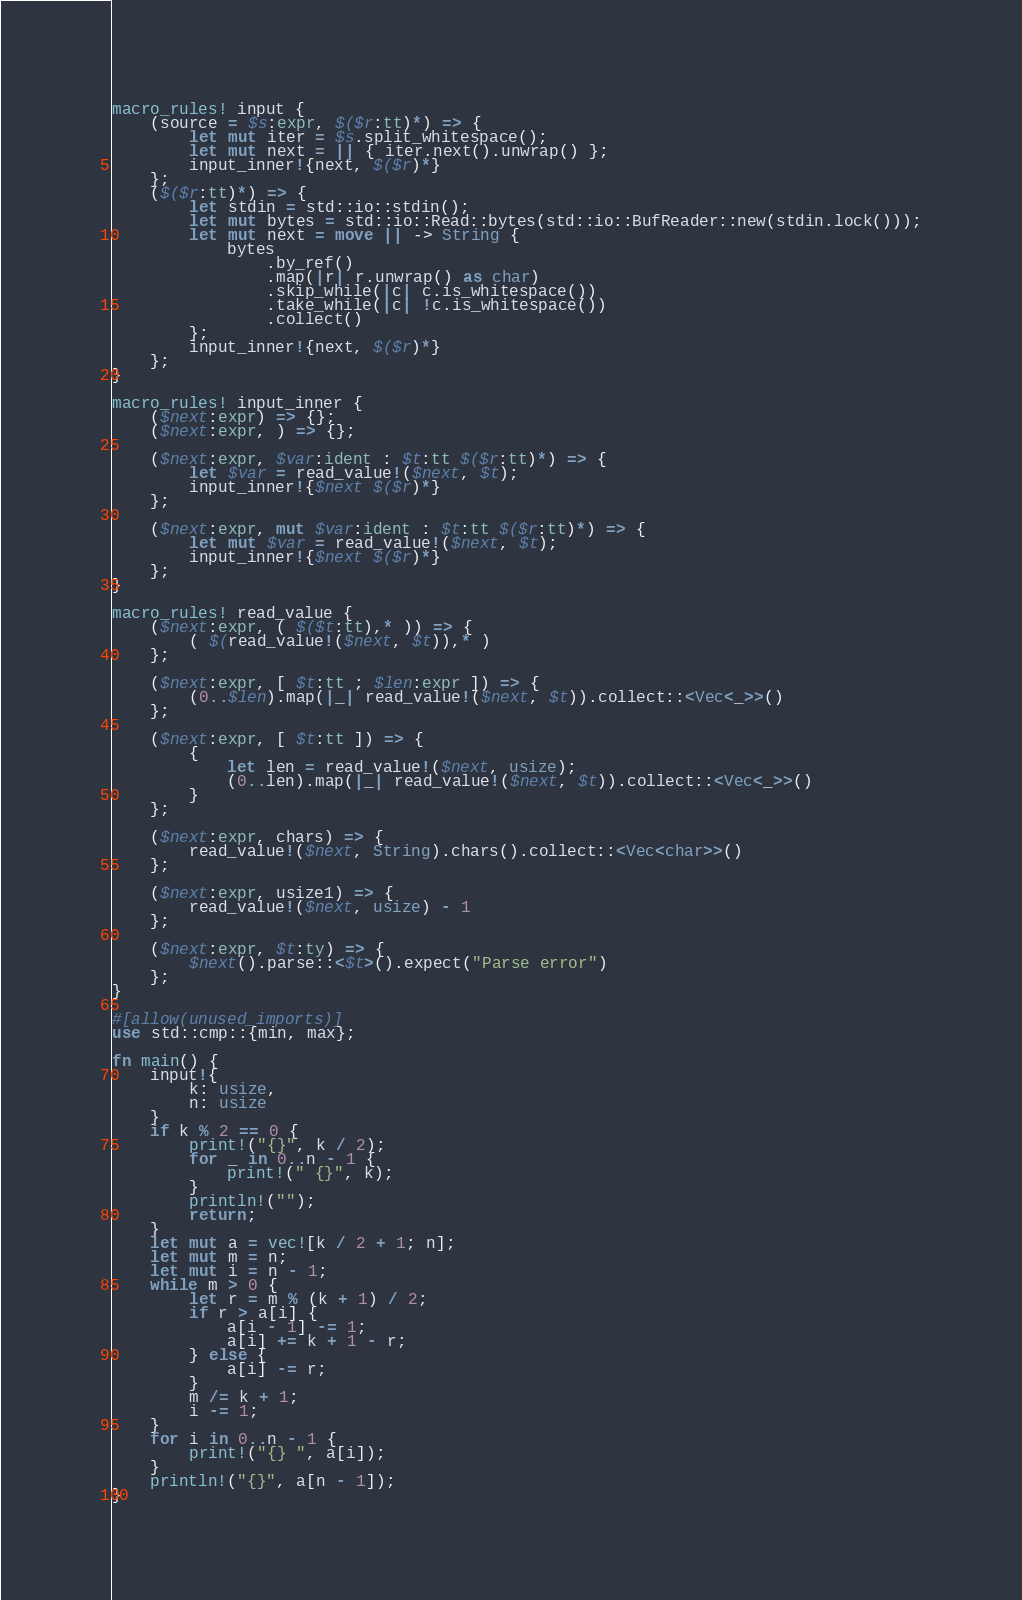<code> <loc_0><loc_0><loc_500><loc_500><_Rust_>macro_rules! input {
    (source = $s:expr, $($r:tt)*) => {
        let mut iter = $s.split_whitespace();
        let mut next = || { iter.next().unwrap() };
        input_inner!{next, $($r)*}
    };
    ($($r:tt)*) => {
        let stdin = std::io::stdin();
        let mut bytes = std::io::Read::bytes(std::io::BufReader::new(stdin.lock()));
        let mut next = move || -> String {
            bytes
                .by_ref()
                .map(|r| r.unwrap() as char)
                .skip_while(|c| c.is_whitespace())
                .take_while(|c| !c.is_whitespace())
                .collect()
        };
        input_inner!{next, $($r)*}
    };
}

macro_rules! input_inner {
    ($next:expr) => {};
    ($next:expr, ) => {};

    ($next:expr, $var:ident : $t:tt $($r:tt)*) => {
        let $var = read_value!($next, $t);
        input_inner!{$next $($r)*}
    };

    ($next:expr, mut $var:ident : $t:tt $($r:tt)*) => {
        let mut $var = read_value!($next, $t);
        input_inner!{$next $($r)*}
    };
}

macro_rules! read_value {
    ($next:expr, ( $($t:tt),* )) => {
        ( $(read_value!($next, $t)),* )
    };

    ($next:expr, [ $t:tt ; $len:expr ]) => {
        (0..$len).map(|_| read_value!($next, $t)).collect::<Vec<_>>()
    };

    ($next:expr, [ $t:tt ]) => {
        {
            let len = read_value!($next, usize);
            (0..len).map(|_| read_value!($next, $t)).collect::<Vec<_>>()
        }
    };

    ($next:expr, chars) => {
        read_value!($next, String).chars().collect::<Vec<char>>()
    };

    ($next:expr, usize1) => {
        read_value!($next, usize) - 1
    };

    ($next:expr, $t:ty) => {
        $next().parse::<$t>().expect("Parse error")
    };
}

#[allow(unused_imports)]
use std::cmp::{min, max};

fn main() {
    input!{
        k: usize,
        n: usize
    }
    if k % 2 == 0 {
        print!("{}", k / 2);
        for _ in 0..n - 1 {
            print!(" {}", k);
        }
        println!("");
        return;
    }
    let mut a = vec![k / 2 + 1; n];
    let mut m = n;
    let mut i = n - 1;
    while m > 0 {
        let r = m % (k + 1) / 2;
        if r > a[i] {
            a[i - 1] -= 1;
            a[i] += k + 1 - r;
        } else {
            a[i] -= r;
        }
        m /= k + 1;
        i -= 1;
    }
    for i in 0..n - 1 {
        print!("{} ", a[i]);
    }
    println!("{}", a[n - 1]);
}
</code> 